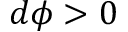<formula> <loc_0><loc_0><loc_500><loc_500>d \phi > 0</formula> 